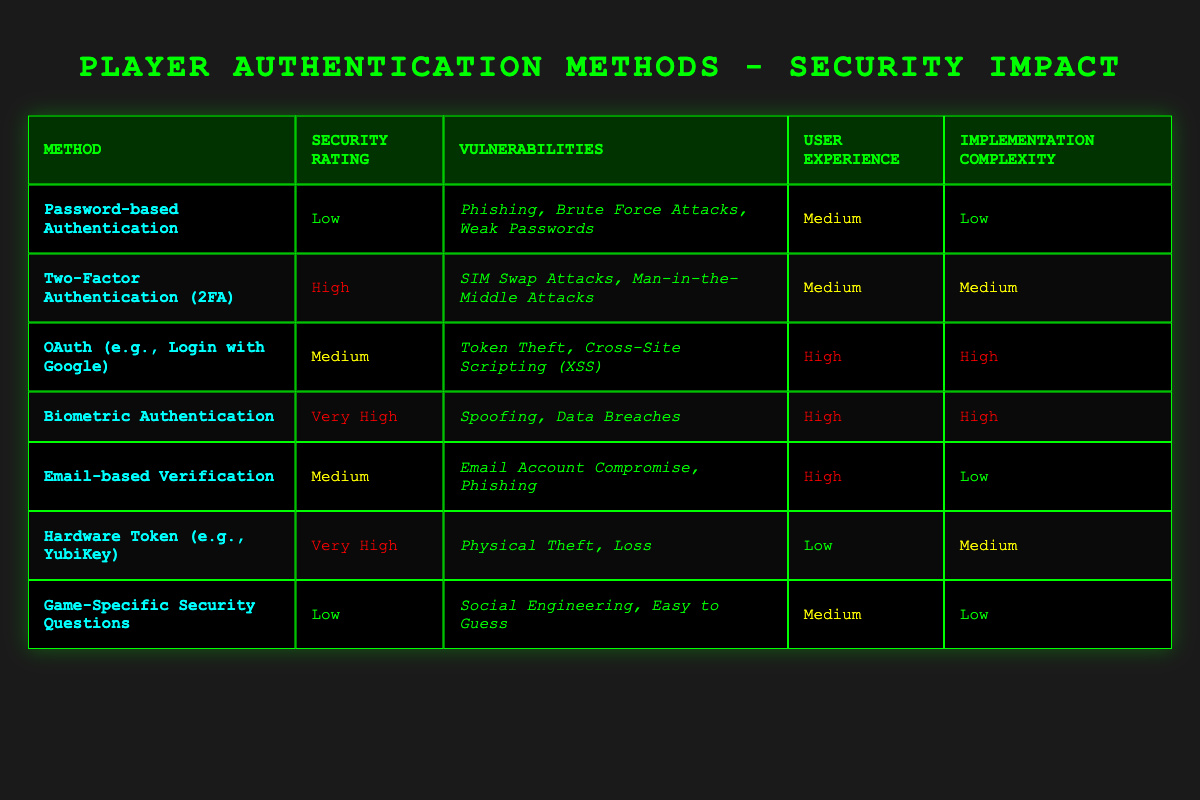What is the security rating of Biometric Authentication? The security rating of Biometric Authentication is stated in the table as "Very High."
Answer: Very High Which authentication method has the highest user experience rating? Biometric Authentication and OAuth both have a user experience rating of "High," which is the highest in the table.
Answer: Biometric Authentication and OAuth Is Password-based Authentication vulnerable to Phishing attacks? Yes, according to the table, Password-based Authentication has vulnerabilities including Phishing.
Answer: Yes What is the average implementation complexity of the player authentication methods listed? The implementation complexities are: Low (3), Medium (3), High (2). This sums to 0 + 1 + 1 + 1 + 1 + 1 + 0 = 5 total points and the average is 5/7 = ~0.71, but since it's categorical and based on qualitative assessment, we see a mix of complexities, with the simplest being "Low" and the most complex "High." A direct average from the numerical values would indicate a predominance of Medium. Hence, while they roughly average toward Medium, a clear average can't be derived from qualitative categories.
Answer: Mostly Medium How many authentication methods have a security rating of High or Very High? The methods with High or Very High security ratings are Two-Factor Authentication, Biometric Authentication, and Hardware Token. This counts as 4 methods in total.
Answer: 4 Are Game-Specific Security Questions regarded as a secure authentication method? No, Game-Specific Security Questions have a "Low" security rating, indicating they are not considered secure.
Answer: No Which authentication method combines a Medium user experience and security rating? The only method that has both Medium user experience and security rating is Email-based Verification.
Answer: Email-based Verification What are the vulnerabilities associated with OAuth authentication? The vulnerabilities listed for OAuth are Token Theft and Cross-Site Scripting (XSS).
Answer: Token Theft, Cross-Site Scripting (XSS) 